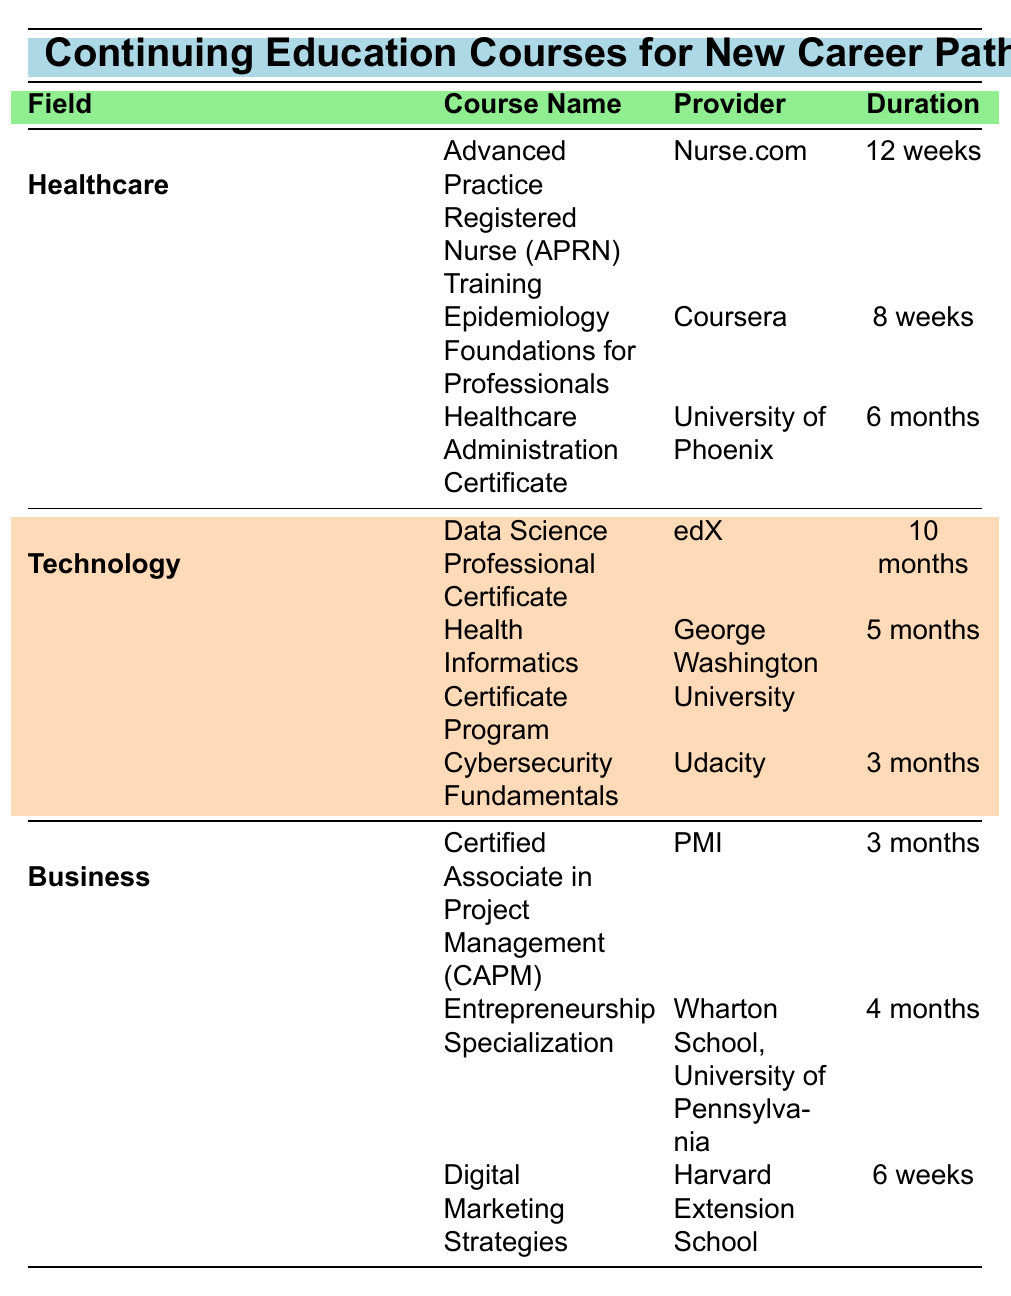What is the duration of the "Epidemiology Foundations for Professionals" course? The course "Epidemiology Foundations for Professionals" is listed under the Healthcare field. Looking at the table, the corresponding duration for this course is specified as 8 weeks.
Answer: 8 weeks Which course has the highest enrollment in the Technology field? In the Technology field, the courses listed with their enrollments are: Data Science Professional Certificate (620), Health Informatics Certificate Program (330), and Cybersecurity Fundamentals (540). The highest enrollment is for the Data Science Professional Certificate with 620 enrollments.
Answer: Data Science Professional Certificate True or False: The "Healthcare Administration Certificate" course has more enrollments than the "Entrepreneurship Specialization" course. The Healthcare Administration Certificate has 280 enrolled, and the Entrepreneurship Specialization has 550 enrolled. Since 280 is less than 550, the statement is false.
Answer: False What is the total enrollment for all courses in the Business field? The Business field includes three courses with the following enrollments: Certified Associate in Project Management (400), Entrepreneurship Specialization (550), and Digital Marketing Strategies (480). To find the total enrollment, sum these numbers: 400 + 550 + 480 = 1430.
Answer: 1430 Which course is provided by the University of Phoenix? In the Healthcare field, the course provided by the University of Phoenix is the "Healthcare Administration Certificate." As noted in the table, this is the only course provided by this institution.
Answer: Healthcare Administration Certificate What is the average duration of courses in the Technology field? The Technology field has three courses with the following durations: Data Science Professional Certificate (10 months), Health Informatics Certificate Program (5 months), and Cybersecurity Fundamentals (3 months). To find the average duration in months, convert them to months: 10, 5, and 3, sum these (10 + 5 + 3 = 18), and divide by the number of courses (3), yielding 18/3 = 6 months.
Answer: 6 months Which provider offers a course that lasts for 6 weeks? The table indicates that the course "Digital Marketing Strategies" lasts for 6 weeks and is offered by Harvard Extension School. This is the only course shown with a duration of 6 weeks.
Answer: Harvard Extension School 